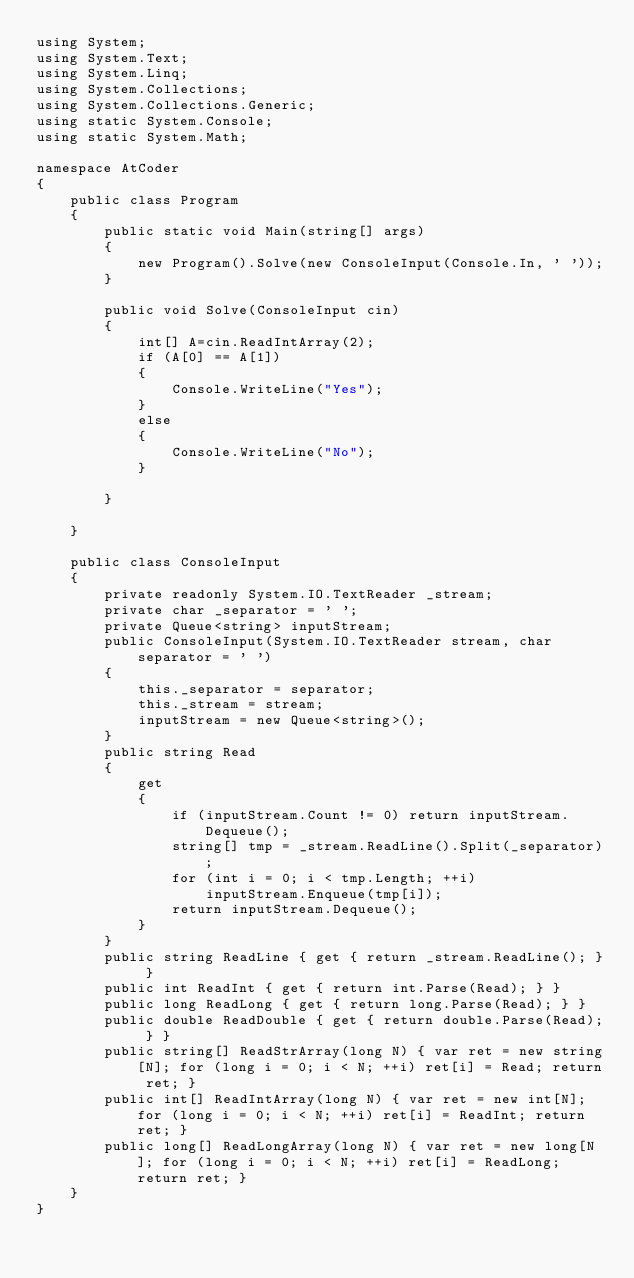<code> <loc_0><loc_0><loc_500><loc_500><_C#_>using System;
using System.Text;
using System.Linq;
using System.Collections;
using System.Collections.Generic;
using static System.Console;
using static System.Math;

namespace AtCoder
{
    public class Program
    {
        public static void Main(string[] args)
        {
            new Program().Solve(new ConsoleInput(Console.In, ' '));
        }

        public void Solve(ConsoleInput cin)
        {
            int[] A=cin.ReadIntArray(2);
            if (A[0] == A[1])
            {
                Console.WriteLine("Yes");
            }
            else
            {
                Console.WriteLine("No");
            }

        }

    }

    public class ConsoleInput
    {
        private readonly System.IO.TextReader _stream;
        private char _separator = ' ';
        private Queue<string> inputStream;
        public ConsoleInput(System.IO.TextReader stream, char separator = ' ')
        {
            this._separator = separator;
            this._stream = stream;
            inputStream = new Queue<string>();
        }
        public string Read
        {
            get
            {
                if (inputStream.Count != 0) return inputStream.Dequeue();
                string[] tmp = _stream.ReadLine().Split(_separator);
                for (int i = 0; i < tmp.Length; ++i)
                    inputStream.Enqueue(tmp[i]);
                return inputStream.Dequeue();
            }
        }
        public string ReadLine { get { return _stream.ReadLine(); } }
        public int ReadInt { get { return int.Parse(Read); } }
        public long ReadLong { get { return long.Parse(Read); } }
        public double ReadDouble { get { return double.Parse(Read); } }
        public string[] ReadStrArray(long N) { var ret = new string[N]; for (long i = 0; i < N; ++i) ret[i] = Read; return ret; }
        public int[] ReadIntArray(long N) { var ret = new int[N]; for (long i = 0; i < N; ++i) ret[i] = ReadInt; return ret; }
        public long[] ReadLongArray(long N) { var ret = new long[N]; for (long i = 0; i < N; ++i) ret[i] = ReadLong; return ret; }
    }
}</code> 